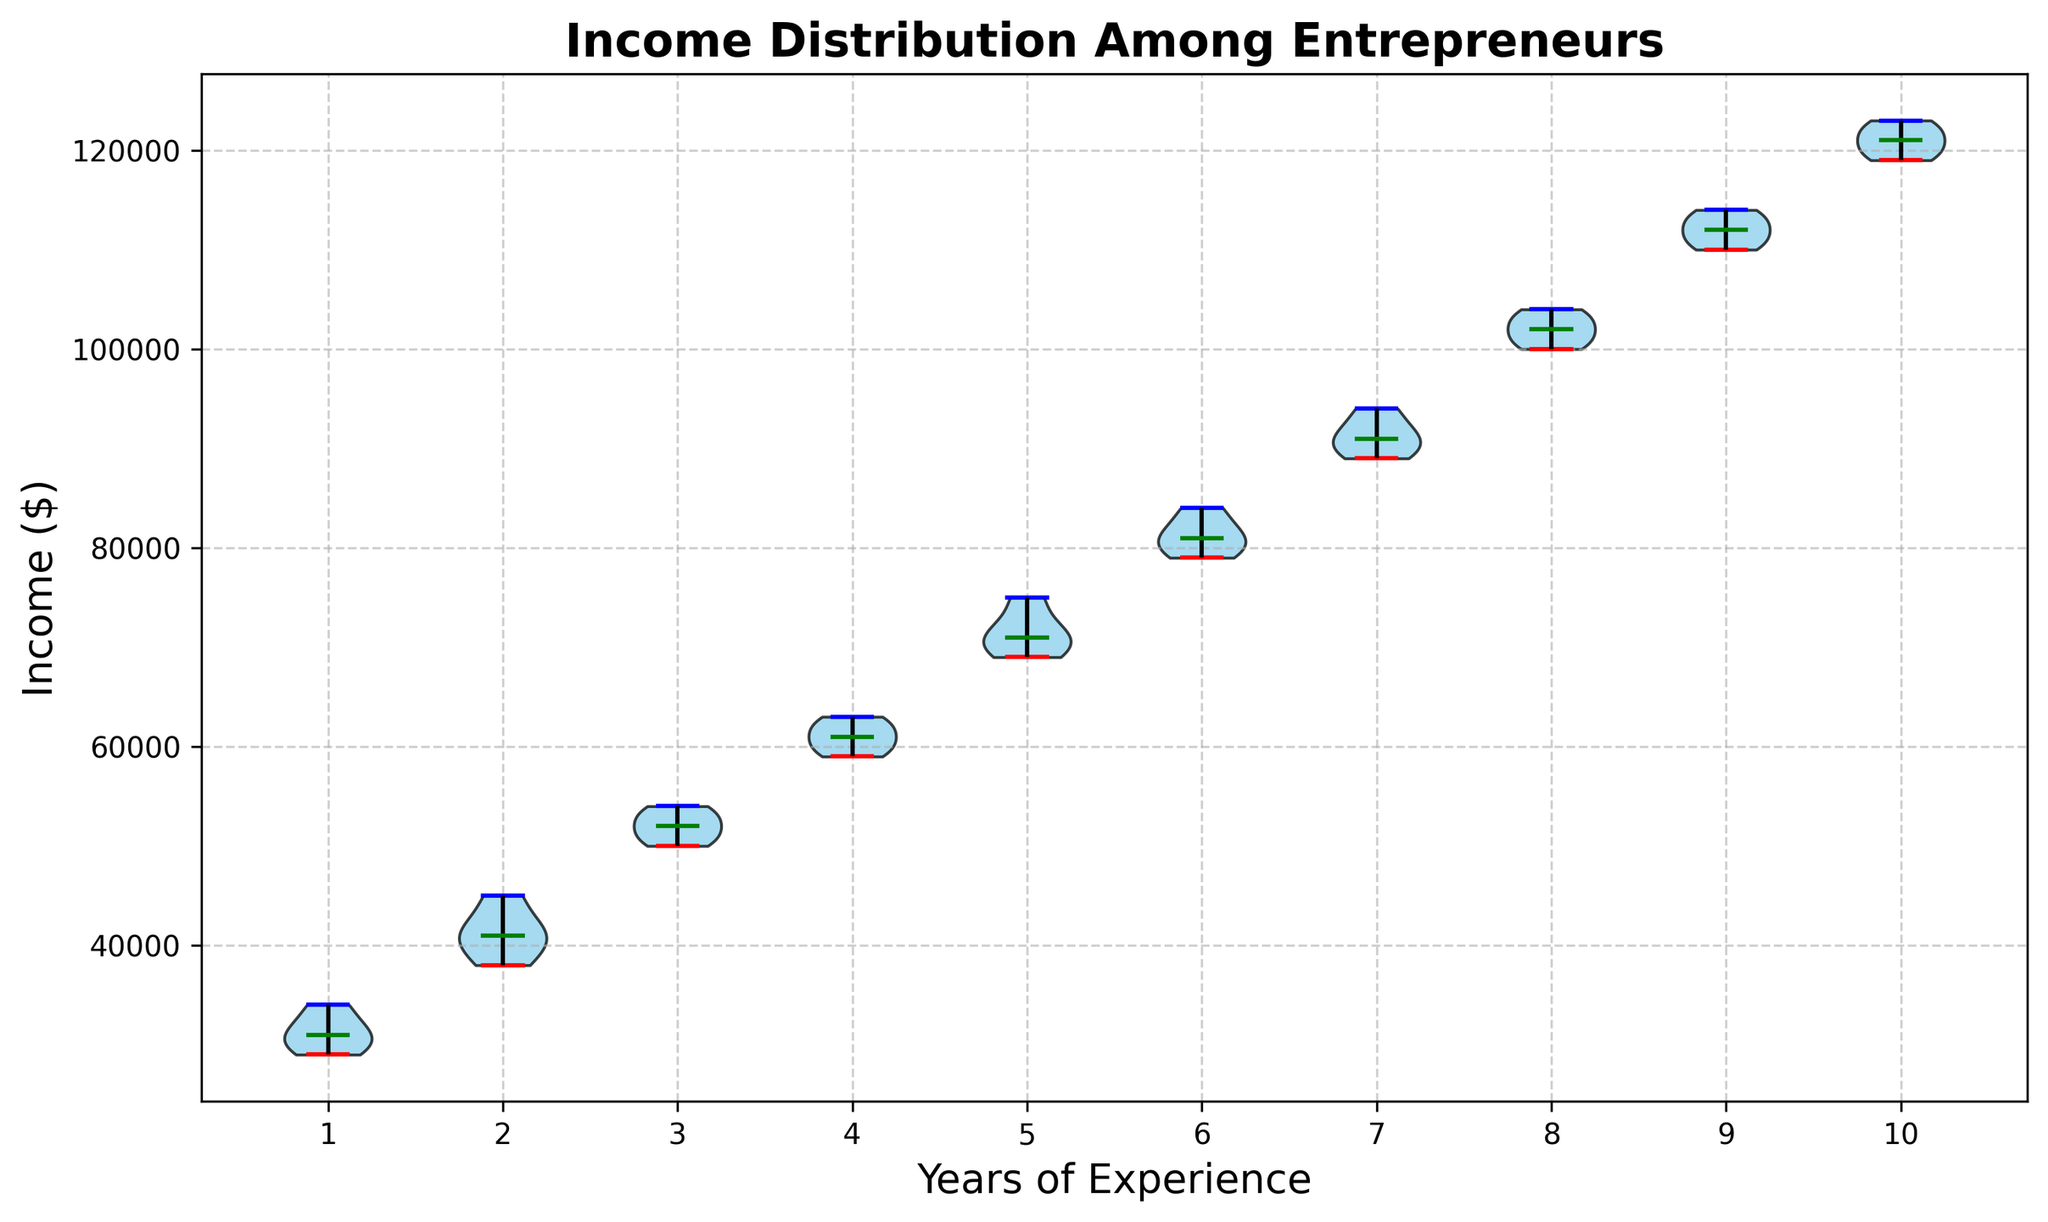What is the median income for entrepreneurs with 3 years of experience? The median income for a group is represented by the green line within the violin plot for that group. For entrepreneurs with 3 years of experience, locate the green line within the third violin.
Answer: 52,000 How does the median income for 5 years of experience compare to 10 years of experience? The median income for a group is indicated by the green line. Compare the green lines for the groups marked 5 and 10 on the x-axis. The median income for 10 years is higher than for 5 years.
Answer: Higher for 10 years Which experience group has the highest range of incomes? The range of incomes is indicated by the span from the lowest to the highest point in each violin plot, represented by the red and blue lines. Identify the group with the largest vertical spread.
Answer: 10 years What is the income range for entrepreneurs with 2 years of experience? The income range for a group is the span between the lowest (red line) and highest (blue line) points in the violin plot for that group. For 2 years of experience, identify these points.
Answer: 38,000 - 45,000 Which color represents the median income level in the violin plots? Look for the consistent color used for the median line across all the violin plots.
Answer: Green Is the distribution of incomes more spread out for 7 years of experience or 4 years of experience? Assess the width and span of the violin plots for the two experience groups. The width indicates the spread of the distribution; a wider plot means a more spread-out distribution.
Answer: More spread out for 7 years What is the mean income for entrepreneurs with 1 year of experience based on the violin plot? The mean is not directly shown on the violin plot but can be inferred if known that the distribution is relatively symmetric. Given the plotted data seems to focus on extremes and medians, refer to external calculations or approximate by central tendency. From the income data, the mean would be the average of the given values.
Answer: 31,000 For how many years of experience does the income distribution appear to have the least variability? Variability is indicated by the width and length of the violin plot. Identify the plot with the narrowest and shortest shape.
Answer: 1 year Which experience group has the narrowest distribution of incomes? Look at the width of each violin plot. The narrowest shape indicates the group with the least variation in incomes.
Answer: 6 years What can you infer about the general trend of income with increasing years of experience? Observe the median lines or the central tendency in the violin plots along the x-axis. There's a general increasing trend as experience increases.
Answer: Increasing trend 